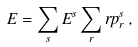<formula> <loc_0><loc_0><loc_500><loc_500>E = \sum _ { s } E ^ { s } \sum _ { r } r p _ { r } ^ { s } \, ,</formula> 